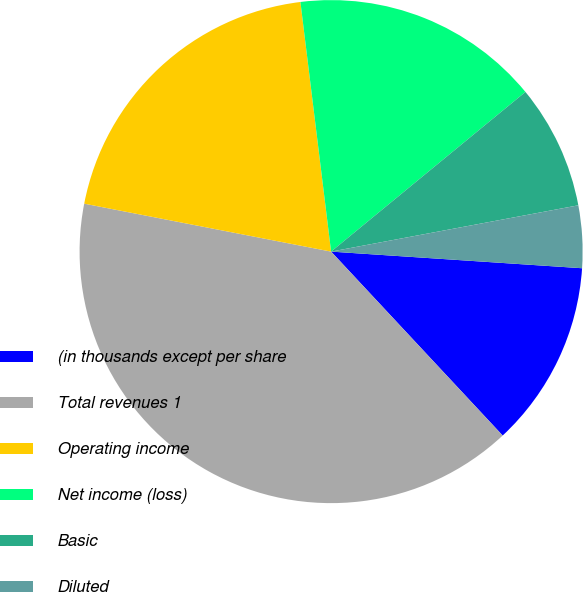Convert chart. <chart><loc_0><loc_0><loc_500><loc_500><pie_chart><fcel>(in thousands except per share<fcel>Total revenues 1<fcel>Operating income<fcel>Net income (loss)<fcel>Basic<fcel>Diluted<fcel>Dividends declared per share<nl><fcel>12.0%<fcel>40.0%<fcel>20.0%<fcel>16.0%<fcel>8.0%<fcel>4.0%<fcel>0.0%<nl></chart> 